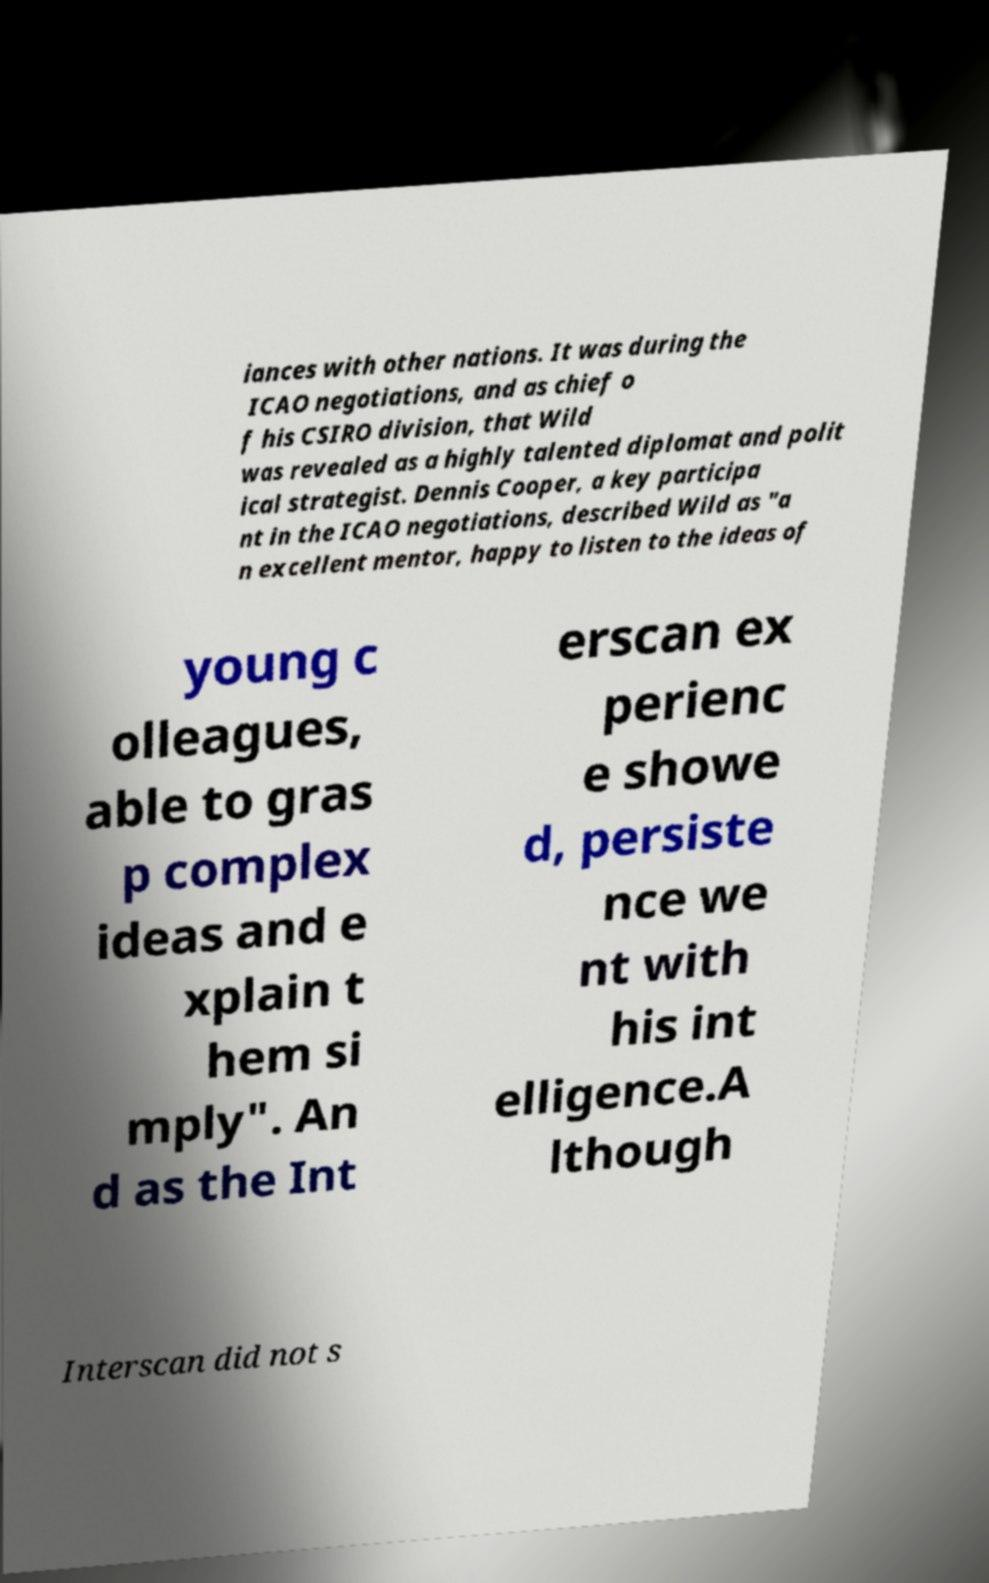Please identify and transcribe the text found in this image. iances with other nations. It was during the ICAO negotiations, and as chief o f his CSIRO division, that Wild was revealed as a highly talented diplomat and polit ical strategist. Dennis Cooper, a key participa nt in the ICAO negotiations, described Wild as "a n excellent mentor, happy to listen to the ideas of young c olleagues, able to gras p complex ideas and e xplain t hem si mply". An d as the Int erscan ex perienc e showe d, persiste nce we nt with his int elligence.A lthough Interscan did not s 